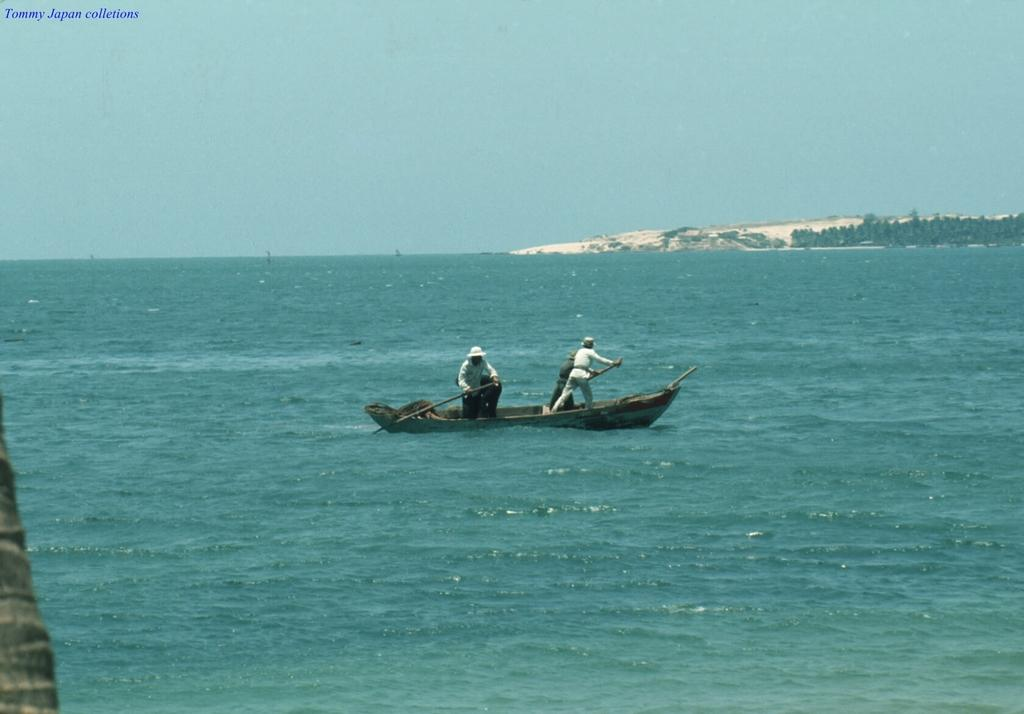What are the two people in the image doing? The two people in the image are rowing a boat. Where is the boat located? The boat is on water. What can be seen on the right side of the image? There are trees on the right side of the image. What is visible at the top of the image? The sky is visible at the top of the image. What type of popcorn is being served in the boat? There is no popcorn present in the image; it features two people rowing a boat on water. What is the source of humor in the image? There is no humor depicted in the image; it shows a straightforward scene of two people rowing a boat on water. 